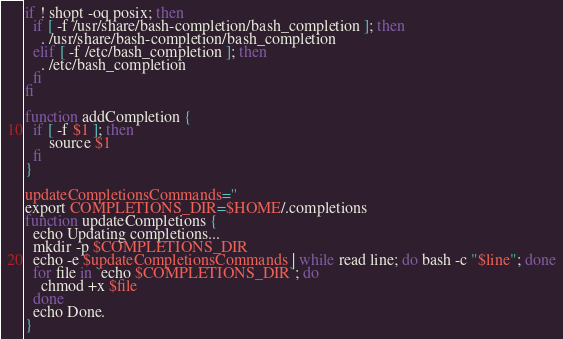<code> <loc_0><loc_0><loc_500><loc_500><_Bash_>if ! shopt -oq posix; then
  if [ -f /usr/share/bash-completion/bash_completion ]; then
    . /usr/share/bash-completion/bash_completion
  elif [ -f /etc/bash_completion ]; then
    . /etc/bash_completion
  fi
fi

function addCompletion {
  if [ -f $1 ]; then
      source $1
  fi
}

updateCompletionsCommands=''
export COMPLETIONS_DIR=$HOME/.completions
function updateCompletions {
  echo Updating completions...
  mkdir -p $COMPLETIONS_DIR
  echo -e $updateCompletionsCommands | while read line; do bash -c "$line"; done
  for file in `echo $COMPLETIONS_DIR`; do
    chmod +x $file
  done
  echo Done.
}</code> 